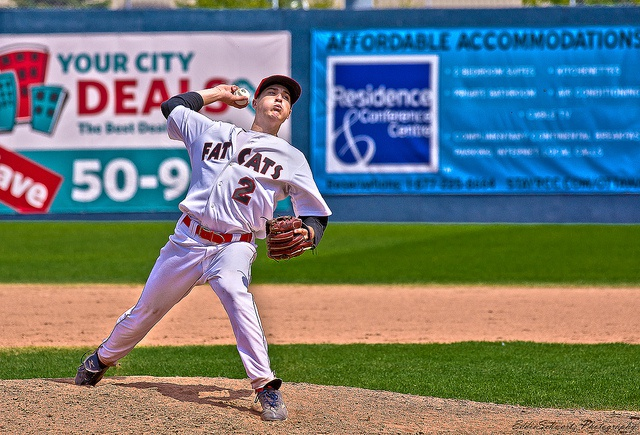Describe the objects in this image and their specific colors. I can see people in tan, lavender, gray, brown, and violet tones, baseball glove in tan, maroon, black, and brown tones, and sports ball in tan, white, gray, and darkgray tones in this image. 